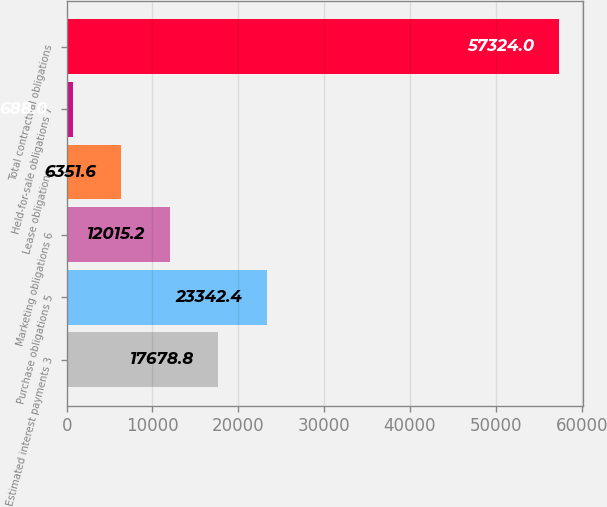Convert chart to OTSL. <chart><loc_0><loc_0><loc_500><loc_500><bar_chart><fcel>Estimated interest payments 3<fcel>Purchase obligations 5<fcel>Marketing obligations 6<fcel>Lease obligations<fcel>Held-for-sale obligations 7<fcel>Total contractual obligations<nl><fcel>17678.8<fcel>23342.4<fcel>12015.2<fcel>6351.6<fcel>688<fcel>57324<nl></chart> 